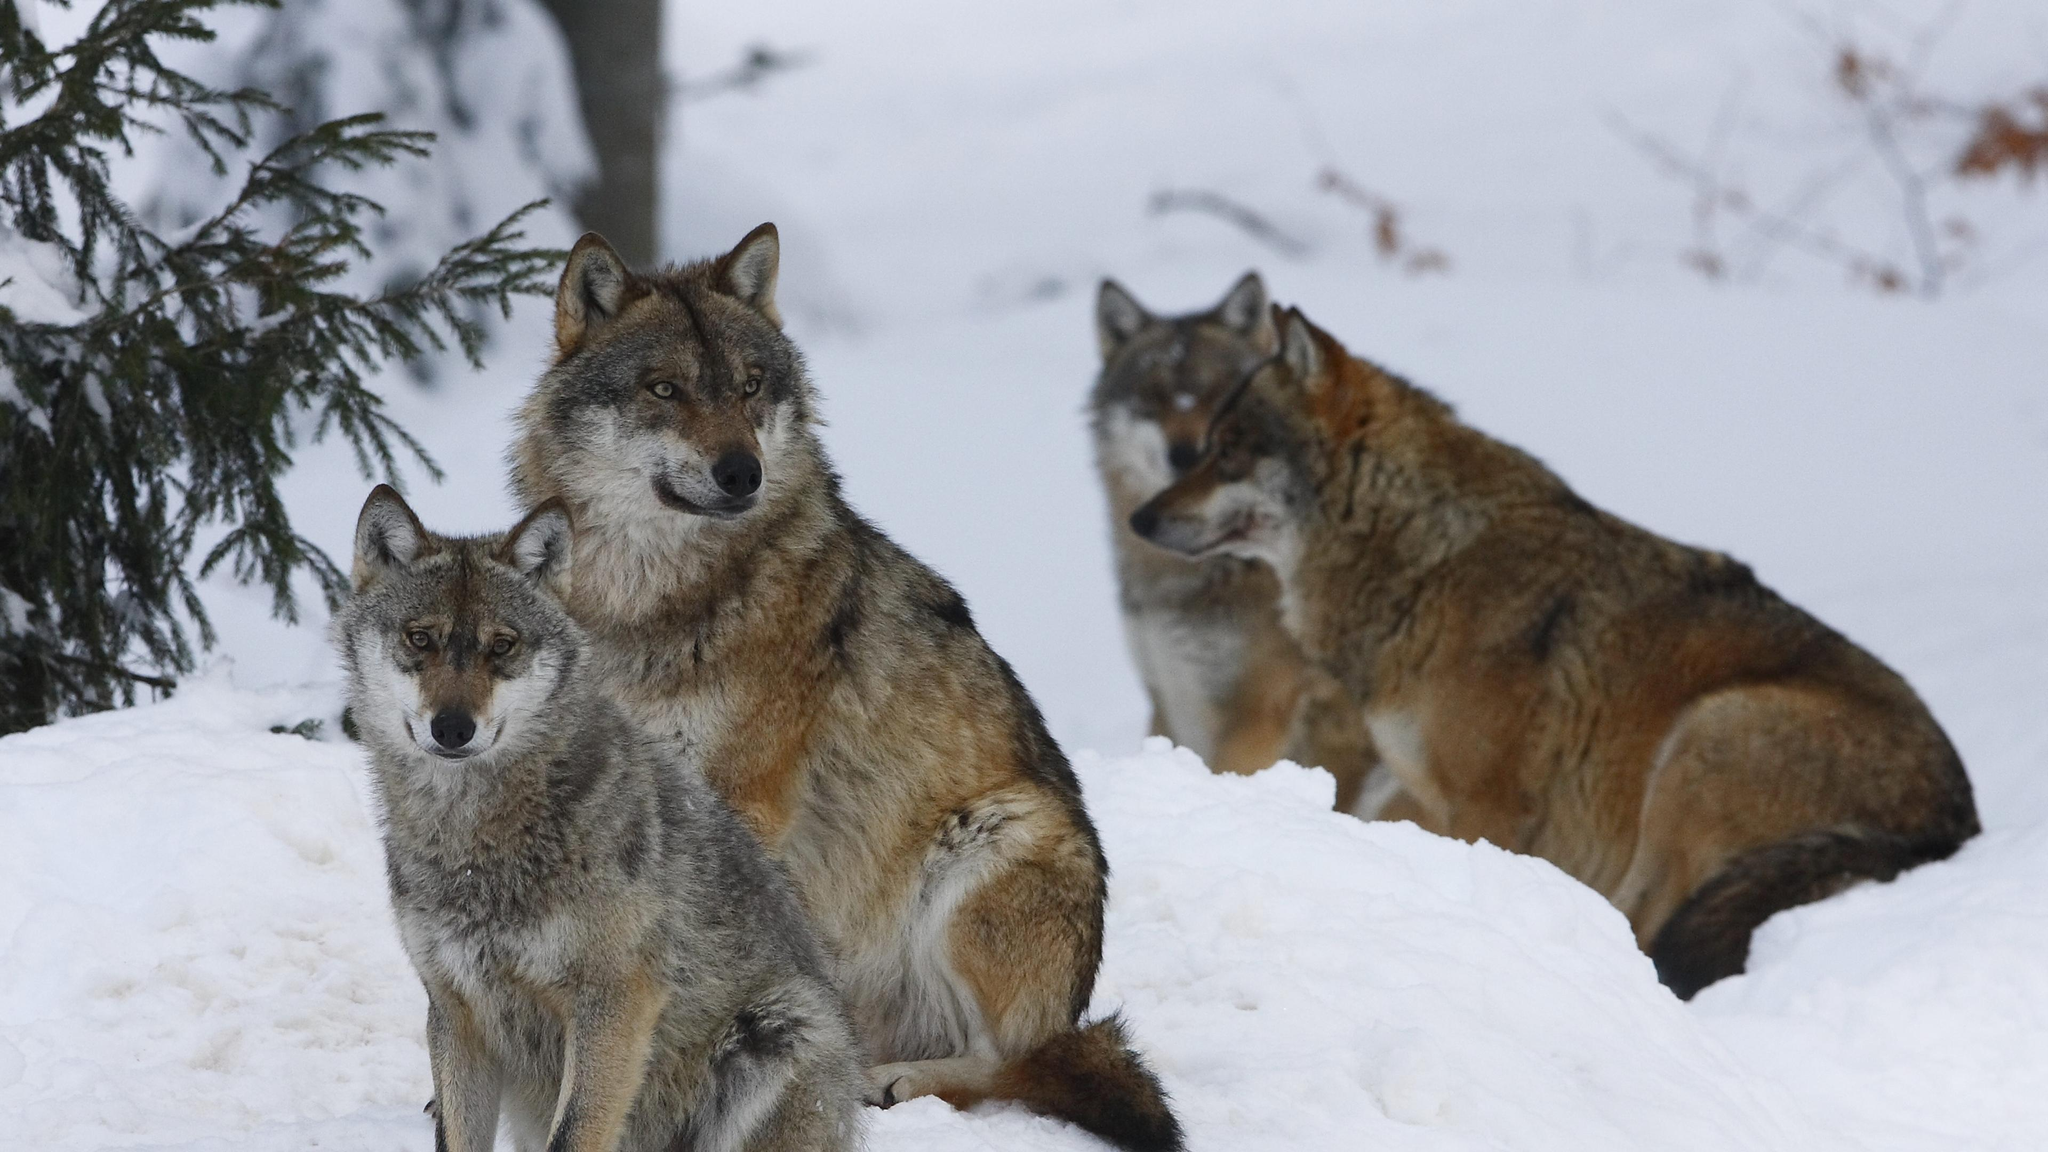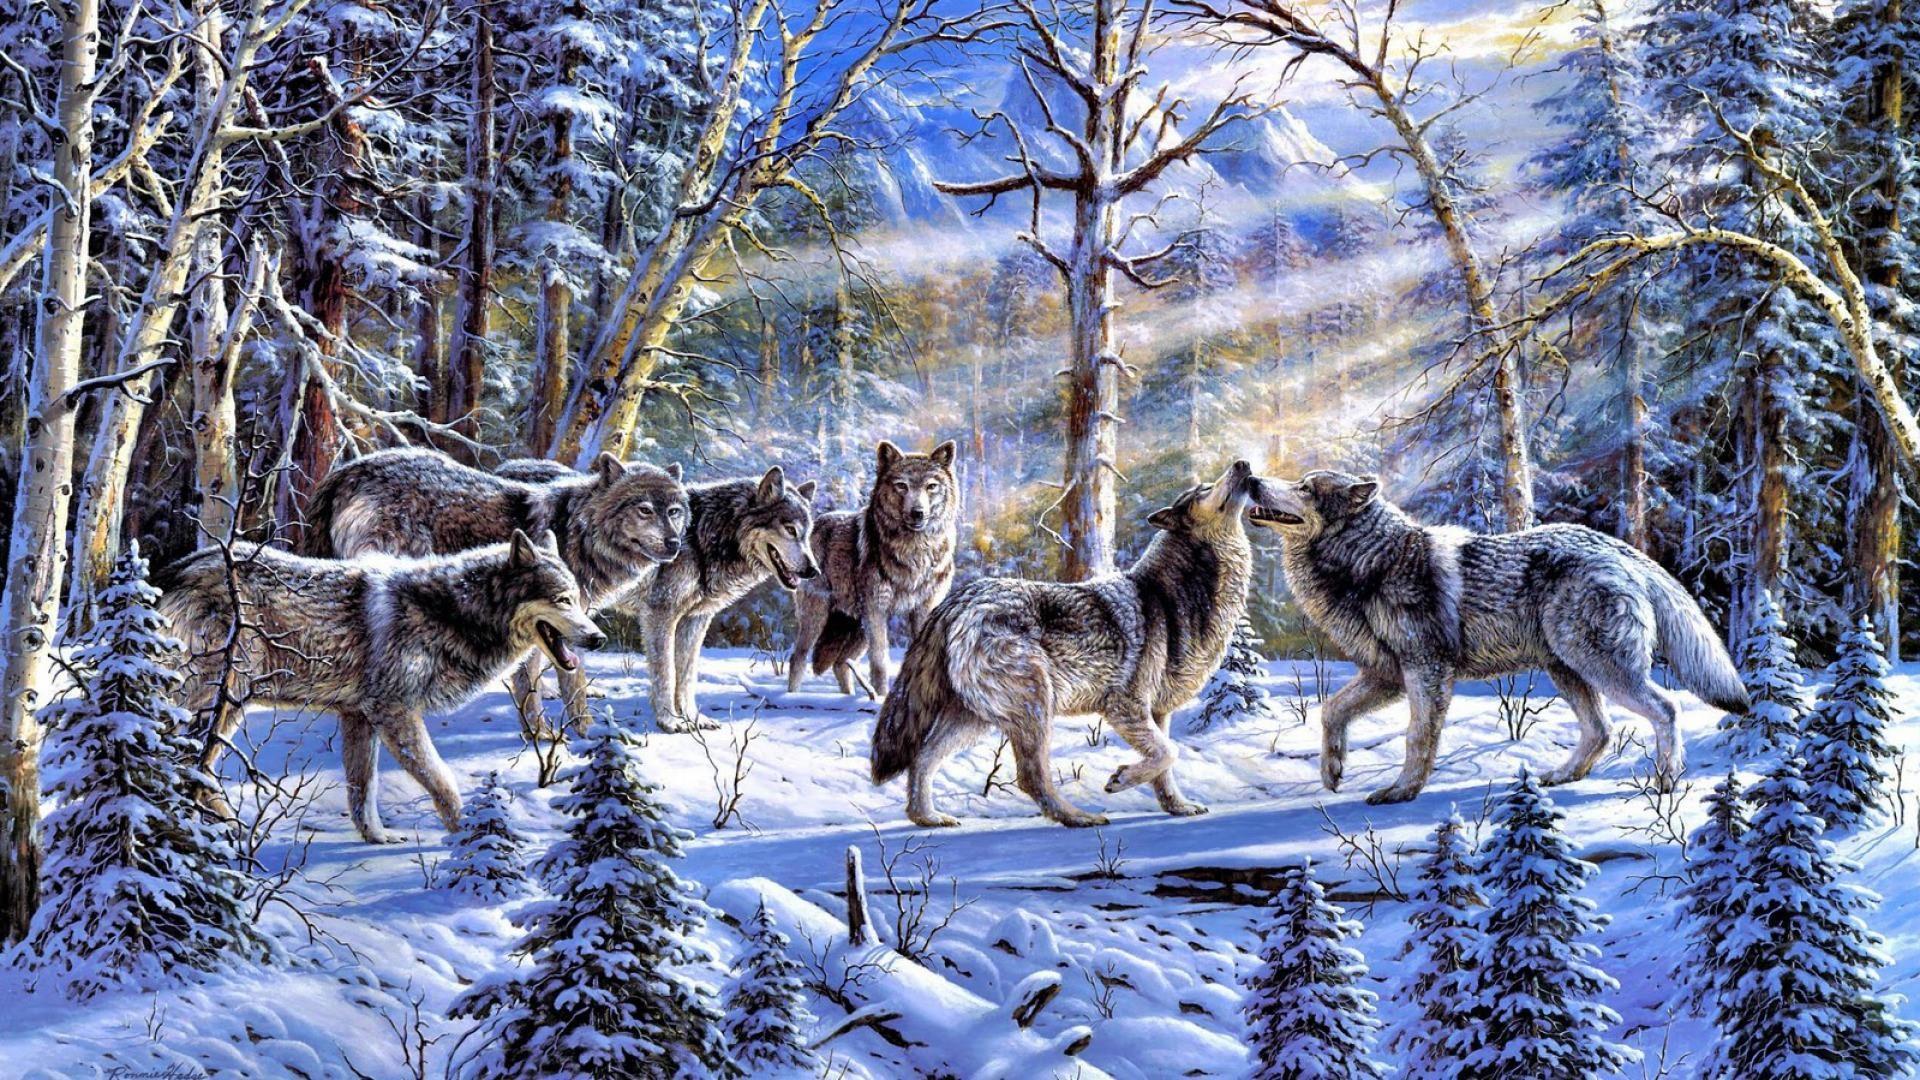The first image is the image on the left, the second image is the image on the right. For the images displayed, is the sentence "One image in the set contains exactly 3 wolves, in a snowy setting with at least one tree in the background." factually correct? Answer yes or no. Yes. The first image is the image on the left, the second image is the image on the right. Evaluate the accuracy of this statement regarding the images: "An image shows only two wolves in a snowy scene.". Is it true? Answer yes or no. No. 